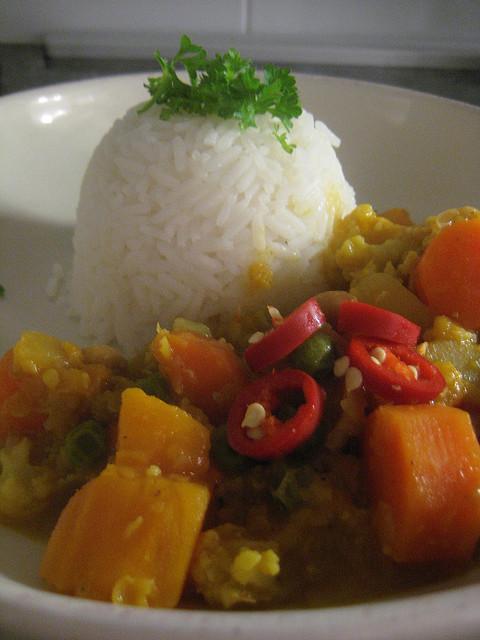What color is the plate?
Short answer required. White. What is the white food?
Quick response, please. Rice. Is this a vegetable soup?
Give a very brief answer. No. What holiday mas this be?
Write a very short answer. Christmas. Are there hot peppers in this meal?
Give a very brief answer. Yes. 